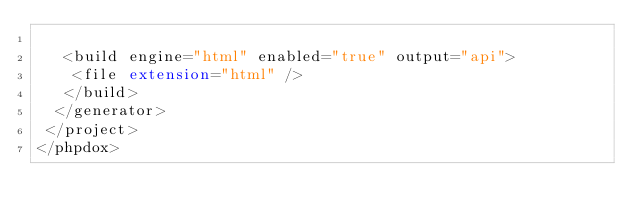Convert code to text. <code><loc_0><loc_0><loc_500><loc_500><_XML_>
   <build engine="html" enabled="true" output="api">
    <file extension="html" />
   </build>
  </generator>
 </project>
</phpdox>

</code> 